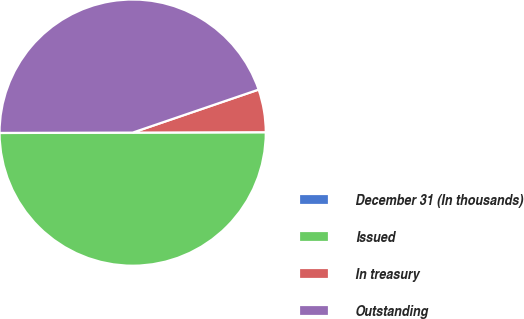<chart> <loc_0><loc_0><loc_500><loc_500><pie_chart><fcel>December 31 (In thousands)<fcel>Issued<fcel>In treasury<fcel>Outstanding<nl><fcel>0.01%<fcel>50.0%<fcel>5.19%<fcel>44.8%<nl></chart> 